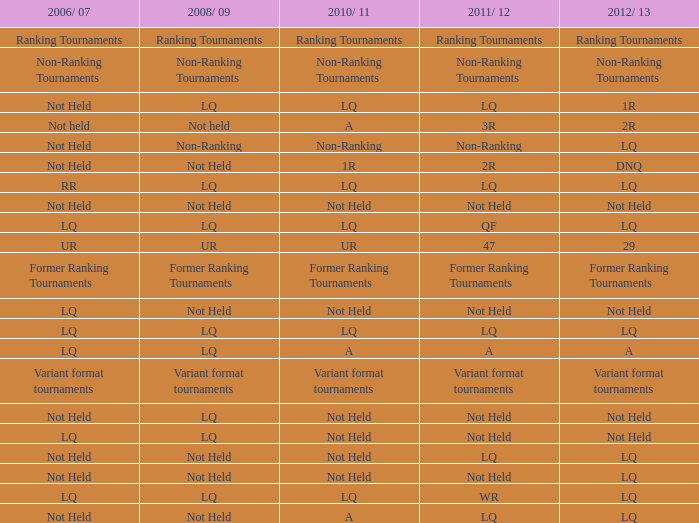Can you parse all the data within this table? {'header': ['2006/ 07', '2008/ 09', '2010/ 11', '2011/ 12', '2012/ 13'], 'rows': [['Ranking Tournaments', 'Ranking Tournaments', 'Ranking Tournaments', 'Ranking Tournaments', 'Ranking Tournaments'], ['Non-Ranking Tournaments', 'Non-Ranking Tournaments', 'Non-Ranking Tournaments', 'Non-Ranking Tournaments', 'Non-Ranking Tournaments'], ['Not Held', 'LQ', 'LQ', 'LQ', '1R'], ['Not held', 'Not held', 'A', '3R', '2R'], ['Not Held', 'Non-Ranking', 'Non-Ranking', 'Non-Ranking', 'LQ'], ['Not Held', 'Not Held', '1R', '2R', 'DNQ'], ['RR', 'LQ', 'LQ', 'LQ', 'LQ'], ['Not Held', 'Not Held', 'Not Held', 'Not Held', 'Not Held'], ['LQ', 'LQ', 'LQ', 'QF', 'LQ'], ['UR', 'UR', 'UR', '47', '29'], ['Former Ranking Tournaments', 'Former Ranking Tournaments', 'Former Ranking Tournaments', 'Former Ranking Tournaments', 'Former Ranking Tournaments'], ['LQ', 'Not Held', 'Not Held', 'Not Held', 'Not Held'], ['LQ', 'LQ', 'LQ', 'LQ', 'LQ'], ['LQ', 'LQ', 'A', 'A', 'A'], ['Variant format tournaments', 'Variant format tournaments', 'Variant format tournaments', 'Variant format tournaments', 'Variant format tournaments'], ['Not Held', 'LQ', 'Not Held', 'Not Held', 'Not Held'], ['LQ', 'LQ', 'Not Held', 'Not Held', 'Not Held'], ['Not Held', 'Not Held', 'Not Held', 'LQ', 'LQ'], ['Not Held', 'Not Held', 'Not Held', 'Not Held', 'LQ'], ['LQ', 'LQ', 'LQ', 'WR', 'LQ'], ['Not Held', 'Not Held', 'A', 'LQ', 'LQ']]} What is 2008/09, when 2010/11 is UR? UR. 